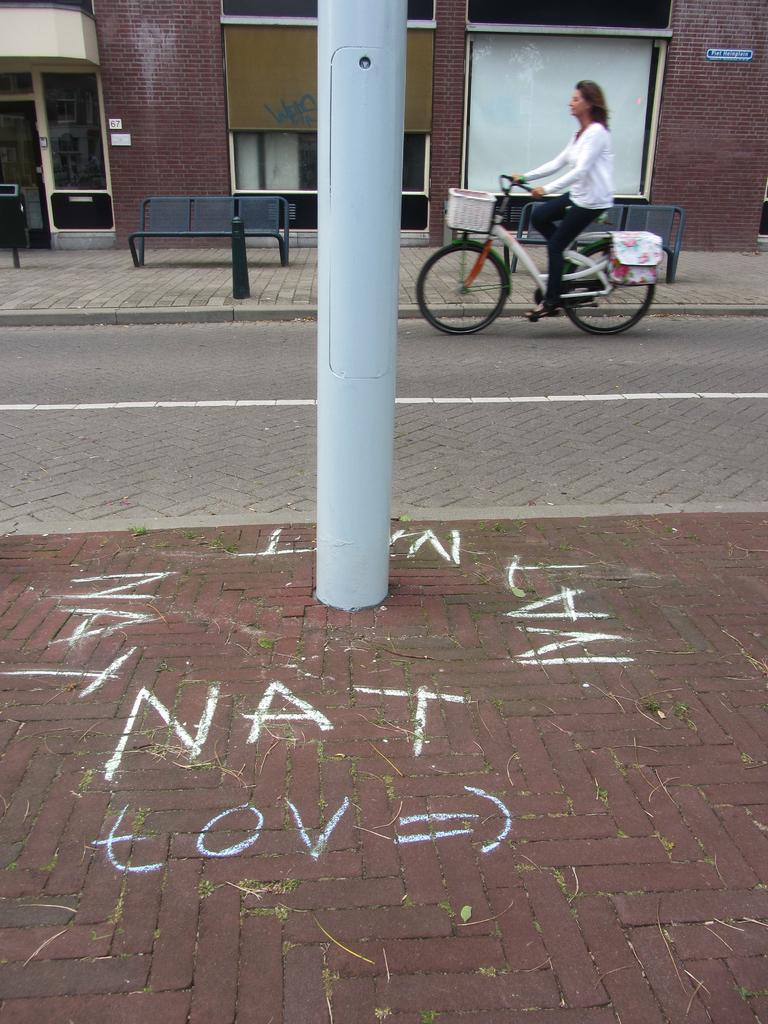What is the woman in the image doing? The woman is riding a bicycle in the image. What structure can be seen in the background of the image? There is a building in the image. What type of outdoor furniture is present in the image? There is a bench in the image. What is located in the center of the image? There is a pole in the center of the image. What type of honey is being sold at the store near the pole in the image? There is no store or honey present in the image; it only features a woman riding a bicycle, a building, a bench, and a pole. 